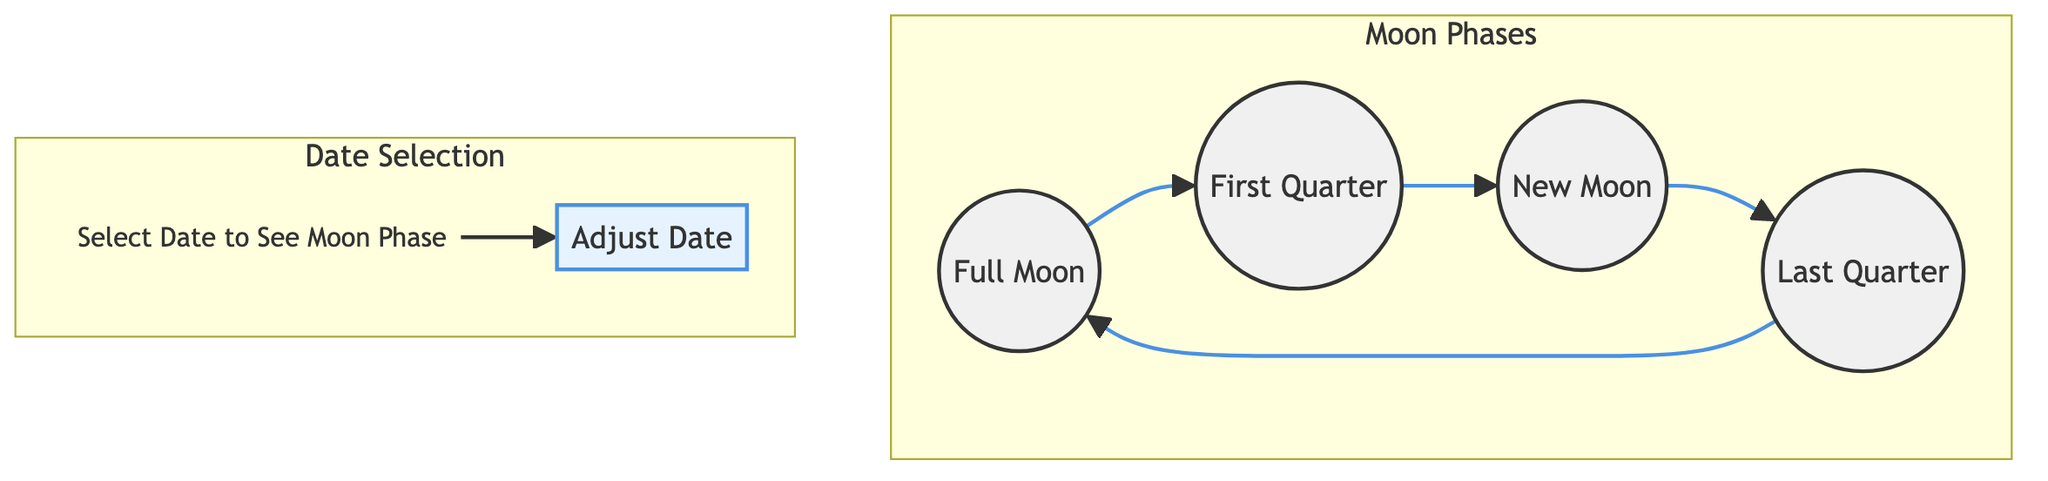What are the phases represented in the diagram? The diagram includes four phases: Full Moon, New Moon, First Quarter, and Last Quarter. These phases are explicitly labeled within the Moon Phases subgraph.
Answer: Full Moon, New Moon, First Quarter, Last Quarter How many nodes are there in the Moon Phases subgraph? The Moon Phases subgraph consists of four nodes: Full Moon, New Moon, First Quarter, and Last Quarter. Each represents a distinct phase of the moon.
Answer: Four What node does the Full Moon lead to? In the flow of the diagram, the Full Moon node connects directly to the First Quarter node. This indicates the progression of phases.
Answer: First Quarter What text is displayed above the adjustable date slider? The text "Select Date to See Moon Phase" is prominently featured above the slider, indicating its function to interact with the diagram.
Answer: Select Date to See Moon Phase How many connections are there in total from the moon phases? There are four connections that depict the flow between the moon phases: Full Moon to First Quarter, First Quarter to New Moon, New Moon to Last Quarter, and Last Quarter back to Full Moon.
Answer: Four What is the color of the New Moon node? The New Moon node is colored black (#333333) while the other moon phases are in white, highlighting the visual differentiation of this particular phase.
Answer: Black Which phase follows the New Moon according to the diagram? The sequence shows that the Last Quarter follows the New Moon directly, indicating the transition in moon phases.
Answer: Last Quarter What is the relationship between First Quarter and Last Quarter in the diagram? The First Quarter node directly points to the New Moon node, which then connects to the Last Quarter, forming a progression of phases from one to the next through the relationships.
Answer: New Moon Why is the date slider important? The date slider allows users to adjust the date to visualize different moon phases corresponding to selected dates, making the interaction dynamic and informative.
Answer: It visualizes different phases 